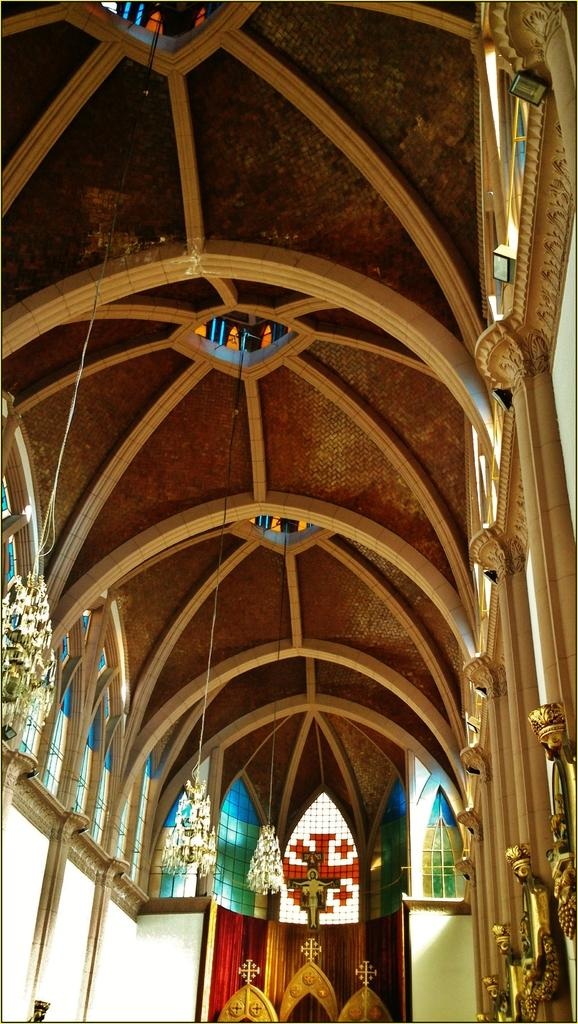What type of location is depicted in the image? The image is an inside view of a building. What can be seen on the right side of the image? There are glass objects and golden objects on the right side of the image. What is located on the left side of the image? There appears to be a chandelier on the left side of the image. What type of company is being discussed in the image? There is no company being discussed in the image; it is a visual representation of a building's interior. What is the plot of the story taking place in the image? There is no story or plot depicted in the image; it is a static representation of a building's interior. 